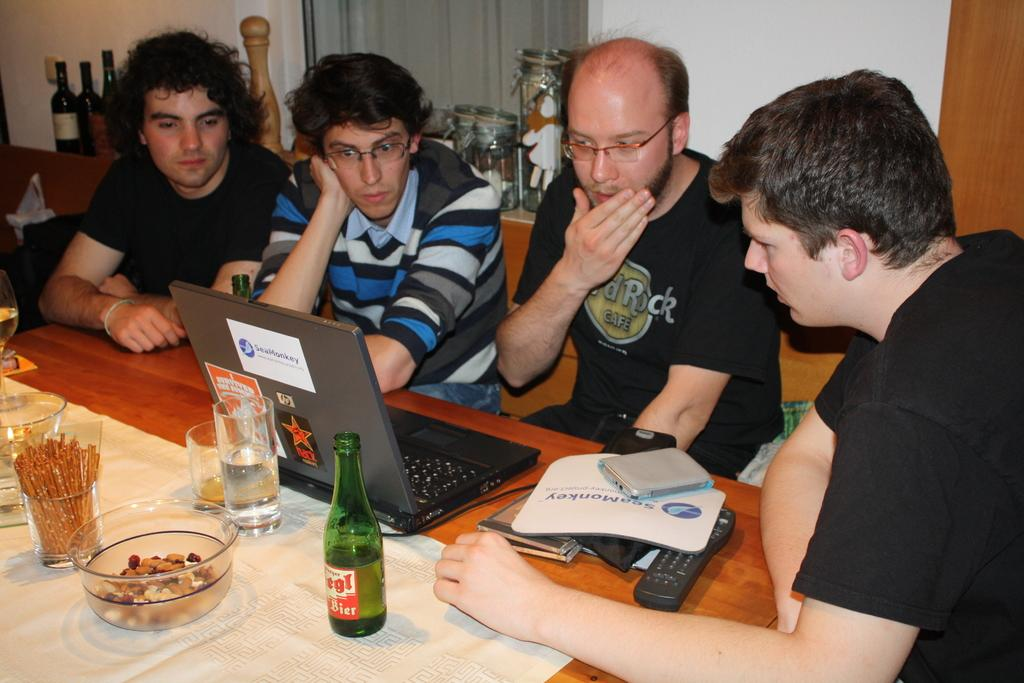How many people are present in the image? There are people in the image, but the exact number is not specified. What type of furniture can be seen in the image? There are tables in the image. What type of containers are visible in the image? There are bottles and jars in the image. What type of window treatment is present in the image? There is a curtain in the image. What type of structure is present in the image? There is a wall in the image. What type of electronic device is on the table in the image? On the table, there is a laptop. What type of drinking vessels are on the table in the image? On the table, there are glasses. What type of container is on the table in the image? On the table, there is a bottle. What type of dish is on the table in the image? On the table, there is a bowl. What type of fabric is on the table in the image? On the table, there is a cloth. What type of print can be seen on the quarter in the image? There is no mention of a quarter in the image, so it cannot be determined if there is any print on it. 